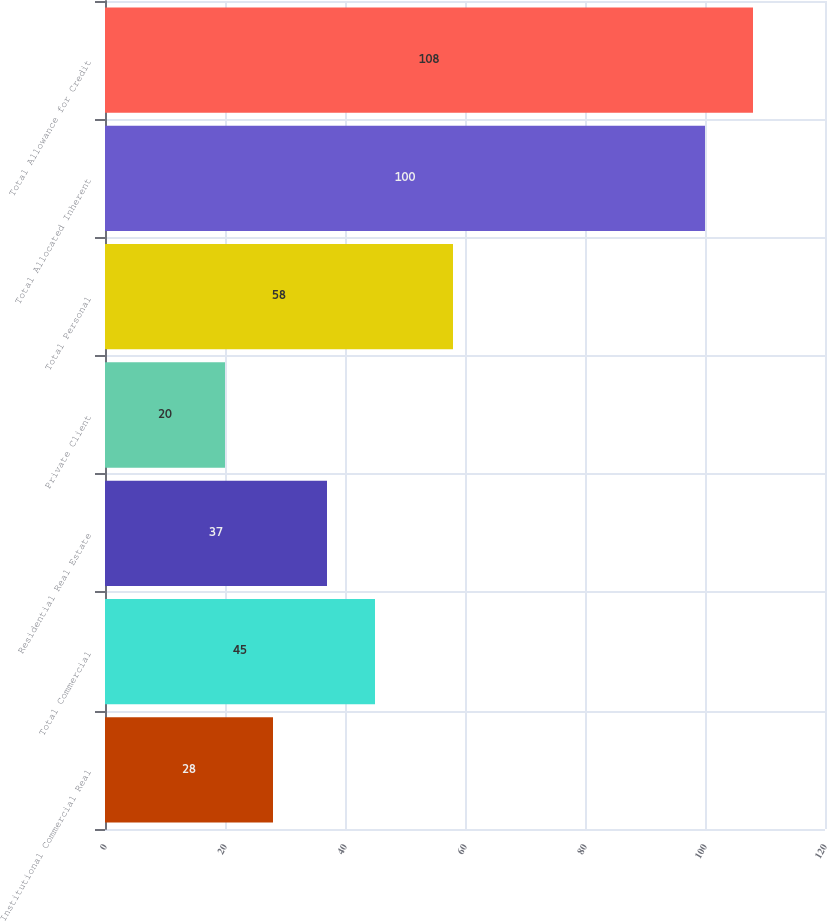Convert chart. <chart><loc_0><loc_0><loc_500><loc_500><bar_chart><fcel>Institutional Commercial Real<fcel>Total Commercial<fcel>Residential Real Estate<fcel>Private Client<fcel>Total Personal<fcel>Total Allocated Inherent<fcel>Total Allowance for Credit<nl><fcel>28<fcel>45<fcel>37<fcel>20<fcel>58<fcel>100<fcel>108<nl></chart> 